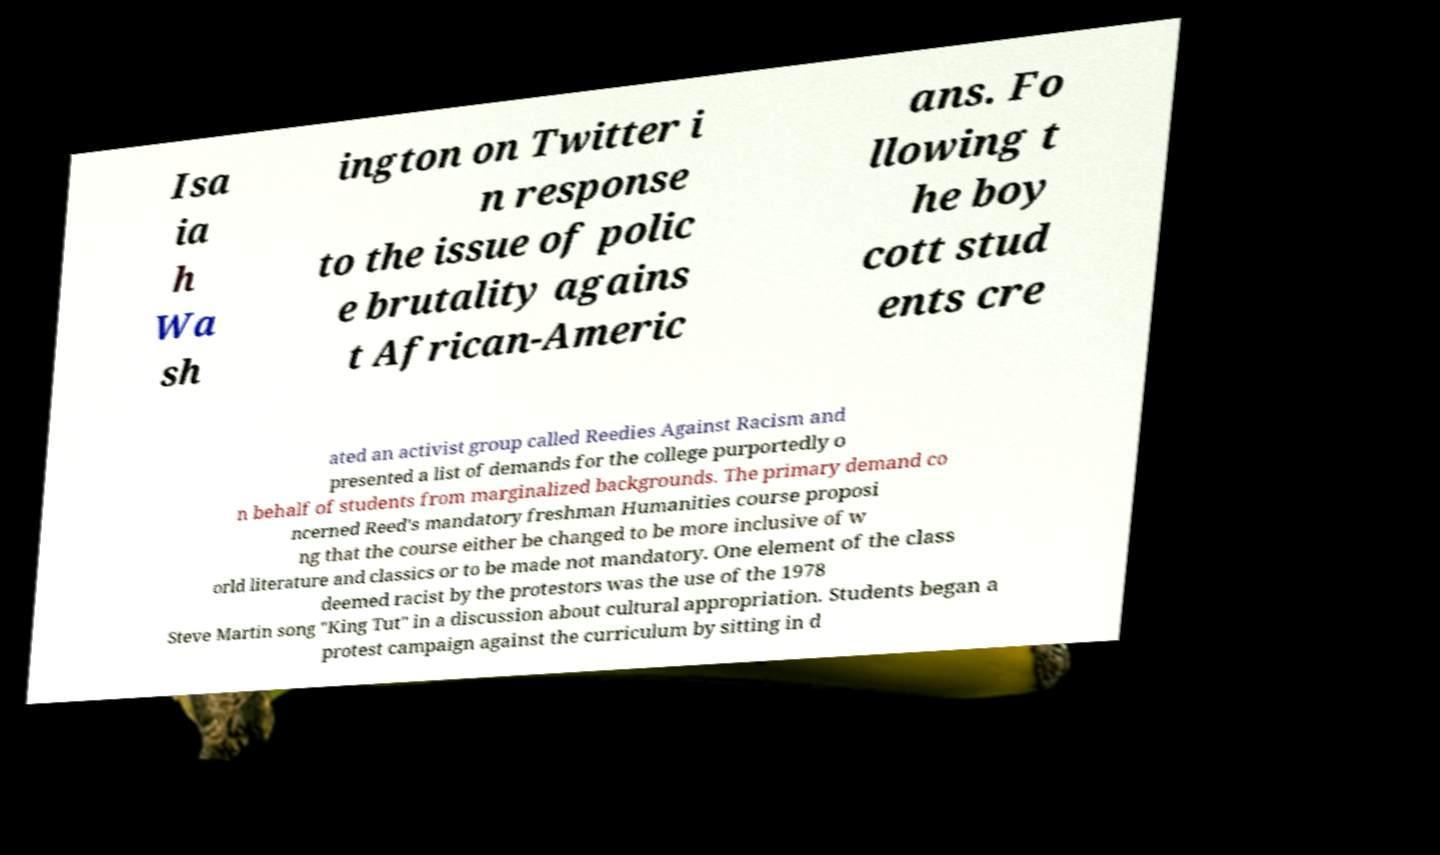Can you read and provide the text displayed in the image?This photo seems to have some interesting text. Can you extract and type it out for me? Isa ia h Wa sh ington on Twitter i n response to the issue of polic e brutality agains t African-Americ ans. Fo llowing t he boy cott stud ents cre ated an activist group called Reedies Against Racism and presented a list of demands for the college purportedly o n behalf of students from marginalized backgrounds. The primary demand co ncerned Reed's mandatory freshman Humanities course proposi ng that the course either be changed to be more inclusive of w orld literature and classics or to be made not mandatory. One element of the class deemed racist by the protestors was the use of the 1978 Steve Martin song "King Tut" in a discussion about cultural appropriation. Students began a protest campaign against the curriculum by sitting in d 